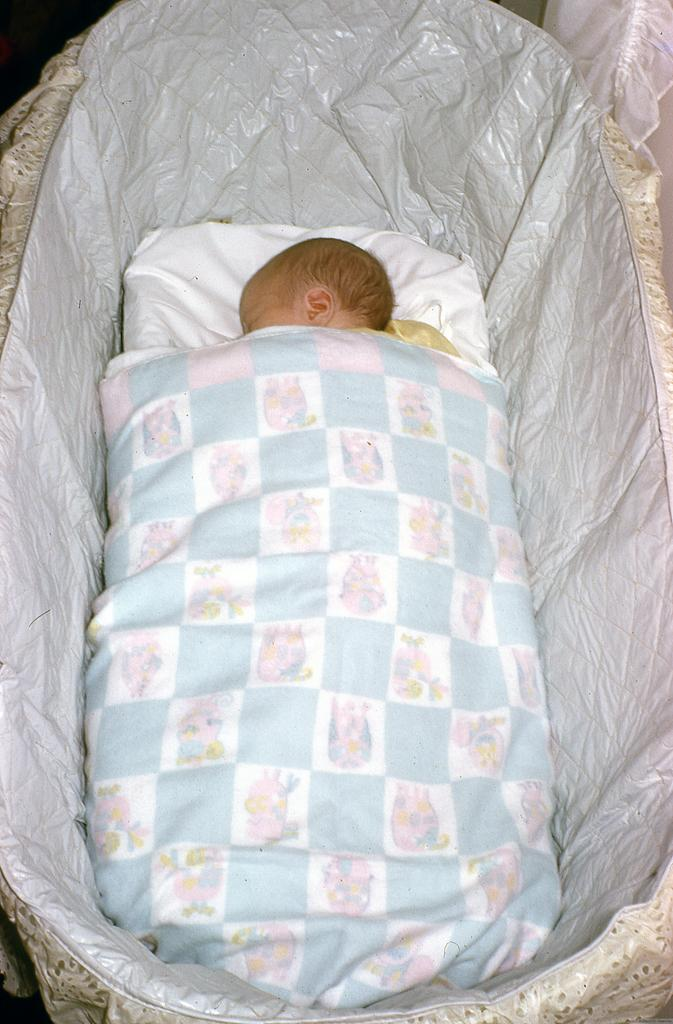What is the main subject of the image? The main subject of the image is a baby. What is the baby doing in the image? The baby is sleeping in the image. Where is the baby located in the image? The baby is on a bed in the image. What is covering the baby in the image? The baby is covered with a blanket in the image. Who is the authority figure in the image? There is no authority figure present in the image, as it features a sleeping baby on a bed. What type of animal can be seen interacting with the baby in the image? There are no animals present in the image; it only features a baby on a bed covered with a blanket. 